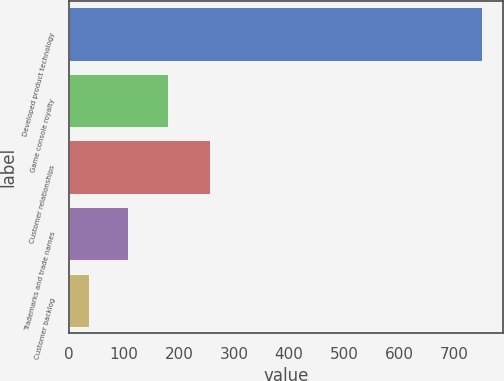Convert chart to OTSL. <chart><loc_0><loc_0><loc_500><loc_500><bar_chart><fcel>Developed product technology<fcel>Game console royalty<fcel>Customer relationships<fcel>Trademarks and trade names<fcel>Customer backlog<nl><fcel>752<fcel>179.2<fcel>257<fcel>107.6<fcel>36<nl></chart> 